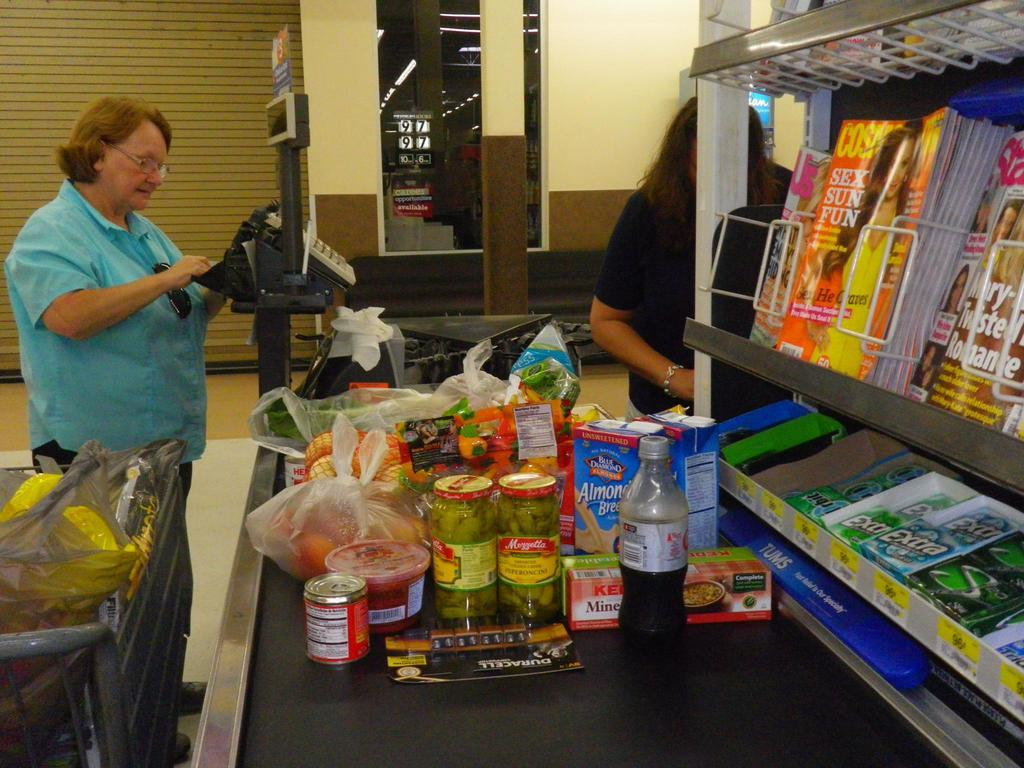<image>
Share a concise interpretation of the image provided. Almond Breeze and other grocery items on the checkout line 